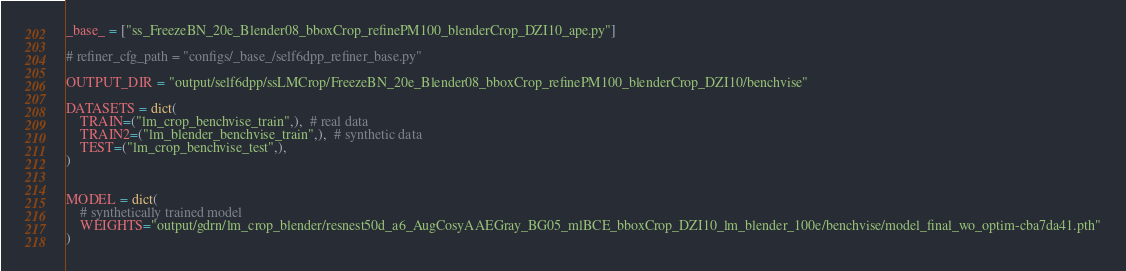<code> <loc_0><loc_0><loc_500><loc_500><_Python_>_base_ = ["ss_FreezeBN_20e_Blender08_bboxCrop_refinePM100_blenderCrop_DZI10_ape.py"]

# refiner_cfg_path = "configs/_base_/self6dpp_refiner_base.py"

OUTPUT_DIR = "output/self6dpp/ssLMCrop/FreezeBN_20e_Blender08_bboxCrop_refinePM100_blenderCrop_DZI10/benchvise"

DATASETS = dict(
    TRAIN=("lm_crop_benchvise_train",),  # real data
    TRAIN2=("lm_blender_benchvise_train",),  # synthetic data
    TEST=("lm_crop_benchvise_test",),
)


MODEL = dict(
    # synthetically trained model
    WEIGHTS="output/gdrn/lm_crop_blender/resnest50d_a6_AugCosyAAEGray_BG05_mlBCE_bboxCrop_DZI10_lm_blender_100e/benchvise/model_final_wo_optim-cba7da41.pth"
)
</code> 